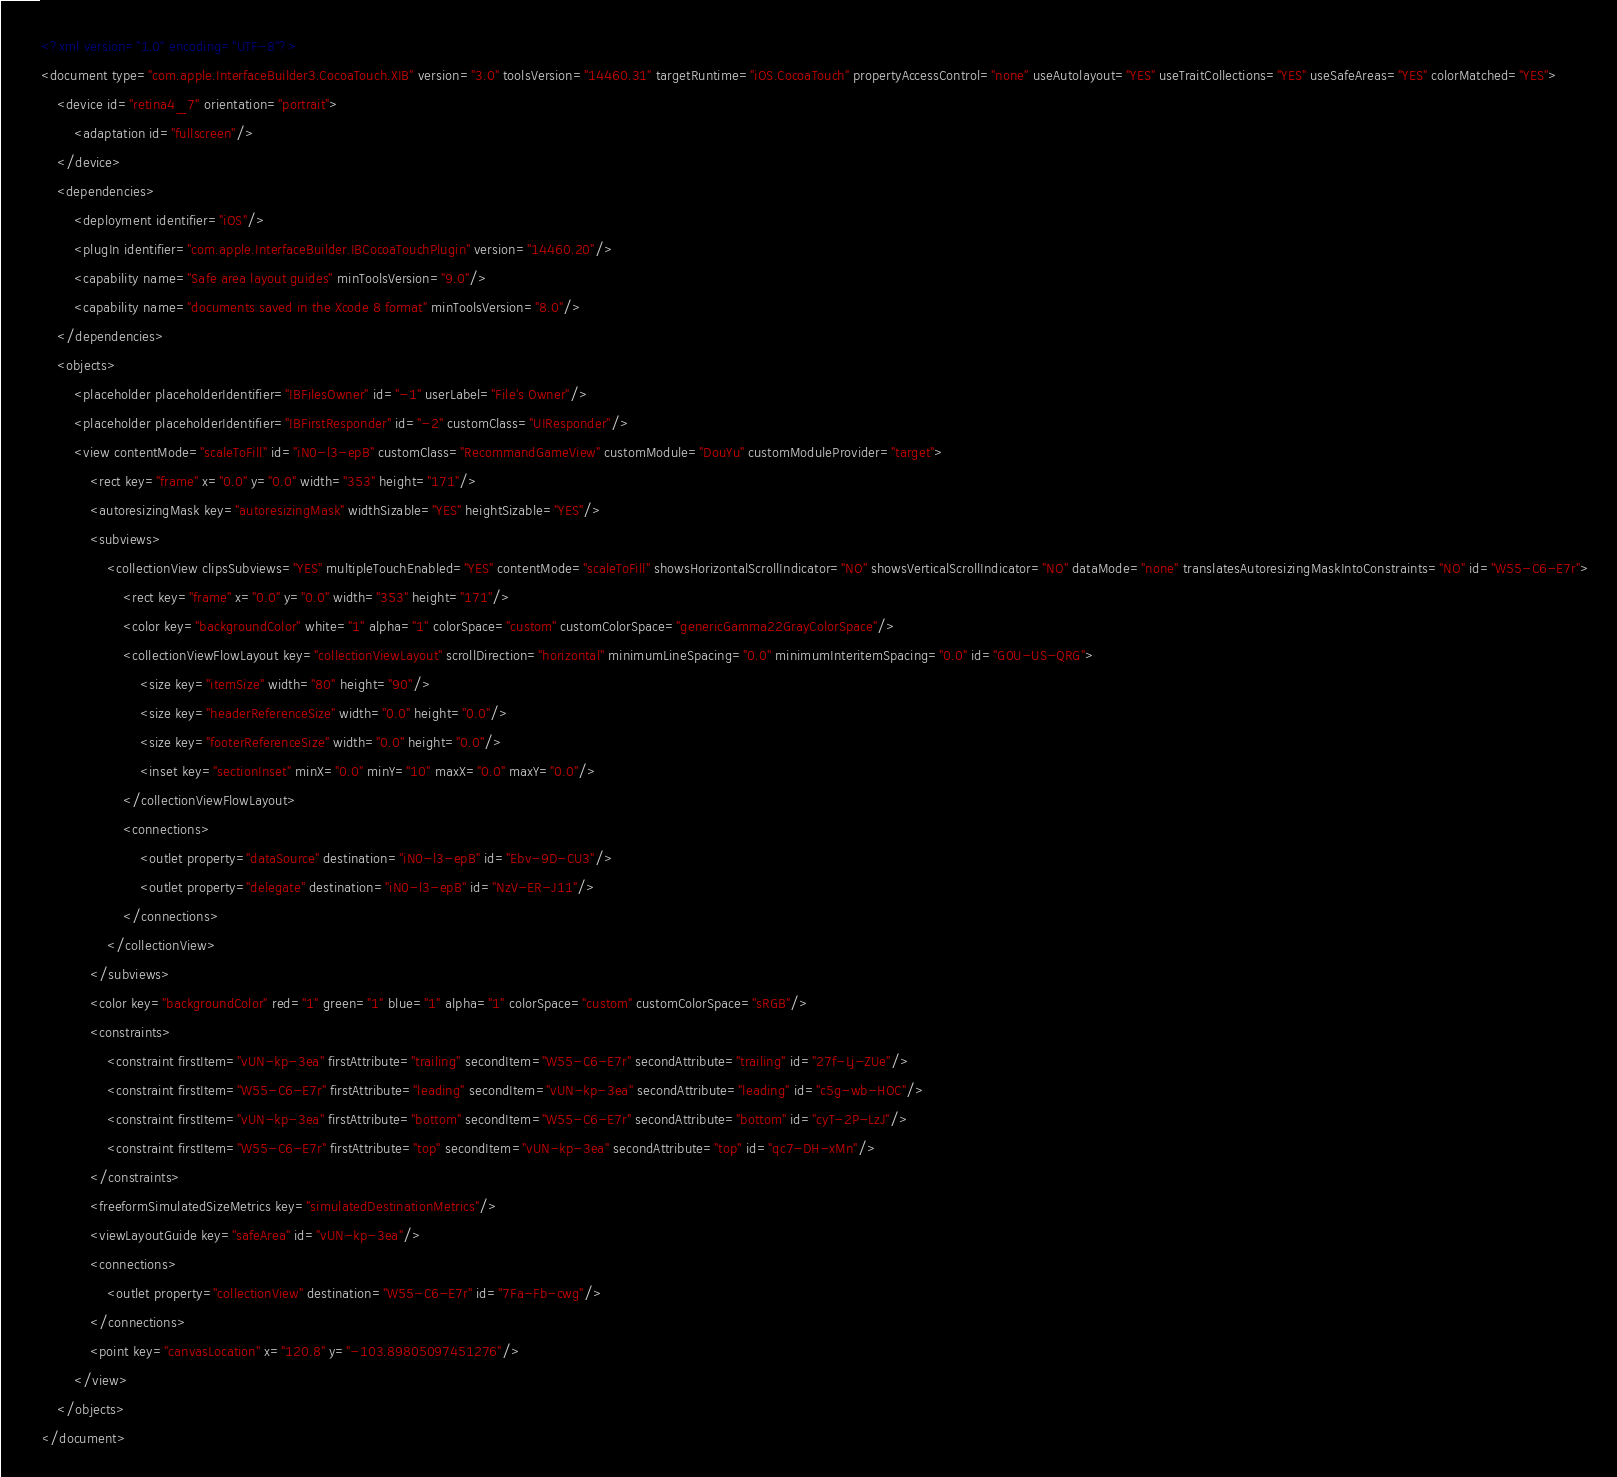<code> <loc_0><loc_0><loc_500><loc_500><_XML_><?xml version="1.0" encoding="UTF-8"?>
<document type="com.apple.InterfaceBuilder3.CocoaTouch.XIB" version="3.0" toolsVersion="14460.31" targetRuntime="iOS.CocoaTouch" propertyAccessControl="none" useAutolayout="YES" useTraitCollections="YES" useSafeAreas="YES" colorMatched="YES">
    <device id="retina4_7" orientation="portrait">
        <adaptation id="fullscreen"/>
    </device>
    <dependencies>
        <deployment identifier="iOS"/>
        <plugIn identifier="com.apple.InterfaceBuilder.IBCocoaTouchPlugin" version="14460.20"/>
        <capability name="Safe area layout guides" minToolsVersion="9.0"/>
        <capability name="documents saved in the Xcode 8 format" minToolsVersion="8.0"/>
    </dependencies>
    <objects>
        <placeholder placeholderIdentifier="IBFilesOwner" id="-1" userLabel="File's Owner"/>
        <placeholder placeholderIdentifier="IBFirstResponder" id="-2" customClass="UIResponder"/>
        <view contentMode="scaleToFill" id="iN0-l3-epB" customClass="RecommandGameView" customModule="DouYu" customModuleProvider="target">
            <rect key="frame" x="0.0" y="0.0" width="353" height="171"/>
            <autoresizingMask key="autoresizingMask" widthSizable="YES" heightSizable="YES"/>
            <subviews>
                <collectionView clipsSubviews="YES" multipleTouchEnabled="YES" contentMode="scaleToFill" showsHorizontalScrollIndicator="NO" showsVerticalScrollIndicator="NO" dataMode="none" translatesAutoresizingMaskIntoConstraints="NO" id="W55-C6-E7r">
                    <rect key="frame" x="0.0" y="0.0" width="353" height="171"/>
                    <color key="backgroundColor" white="1" alpha="1" colorSpace="custom" customColorSpace="genericGamma22GrayColorSpace"/>
                    <collectionViewFlowLayout key="collectionViewLayout" scrollDirection="horizontal" minimumLineSpacing="0.0" minimumInteritemSpacing="0.0" id="G0U-US-QRG">
                        <size key="itemSize" width="80" height="90"/>
                        <size key="headerReferenceSize" width="0.0" height="0.0"/>
                        <size key="footerReferenceSize" width="0.0" height="0.0"/>
                        <inset key="sectionInset" minX="0.0" minY="10" maxX="0.0" maxY="0.0"/>
                    </collectionViewFlowLayout>
                    <connections>
                        <outlet property="dataSource" destination="iN0-l3-epB" id="Ebv-9D-CU3"/>
                        <outlet property="delegate" destination="iN0-l3-epB" id="NzV-ER-J11"/>
                    </connections>
                </collectionView>
            </subviews>
            <color key="backgroundColor" red="1" green="1" blue="1" alpha="1" colorSpace="custom" customColorSpace="sRGB"/>
            <constraints>
                <constraint firstItem="vUN-kp-3ea" firstAttribute="trailing" secondItem="W55-C6-E7r" secondAttribute="trailing" id="27f-Lj-ZUe"/>
                <constraint firstItem="W55-C6-E7r" firstAttribute="leading" secondItem="vUN-kp-3ea" secondAttribute="leading" id="c5g-wb-HOC"/>
                <constraint firstItem="vUN-kp-3ea" firstAttribute="bottom" secondItem="W55-C6-E7r" secondAttribute="bottom" id="cyT-2P-LzJ"/>
                <constraint firstItem="W55-C6-E7r" firstAttribute="top" secondItem="vUN-kp-3ea" secondAttribute="top" id="qc7-DH-xMn"/>
            </constraints>
            <freeformSimulatedSizeMetrics key="simulatedDestinationMetrics"/>
            <viewLayoutGuide key="safeArea" id="vUN-kp-3ea"/>
            <connections>
                <outlet property="collectionView" destination="W55-C6-E7r" id="7Fa-Fb-cwg"/>
            </connections>
            <point key="canvasLocation" x="120.8" y="-103.89805097451276"/>
        </view>
    </objects>
</document>
</code> 